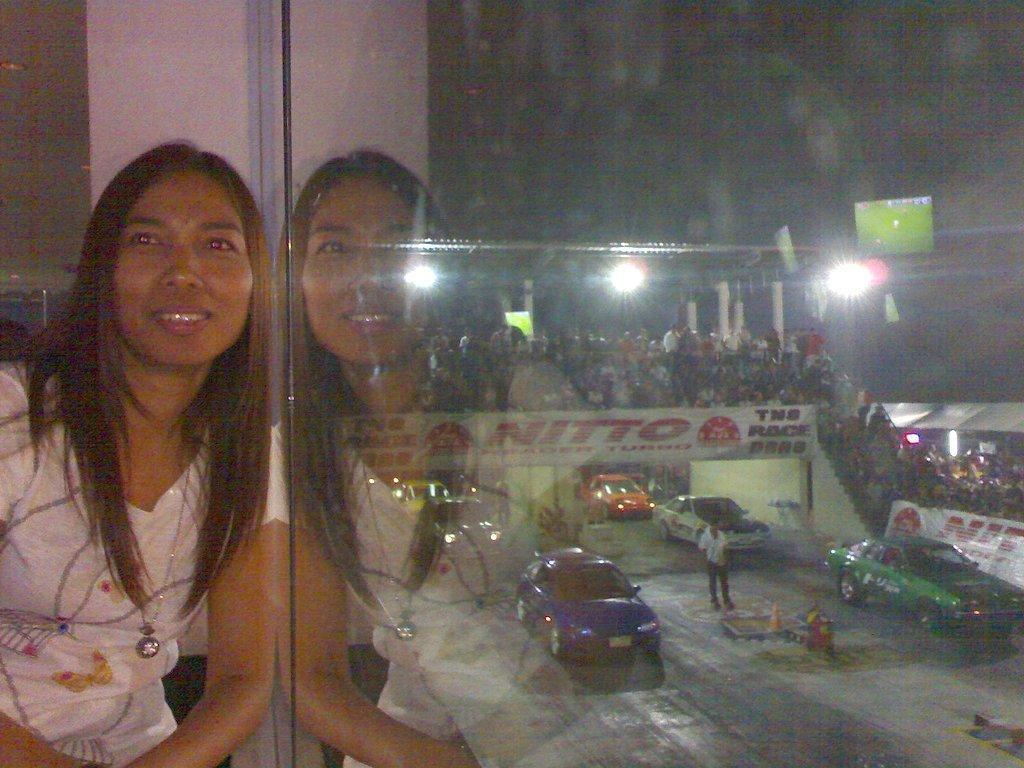In one or two sentences, can you explain what this image depicts? In this image we can see a woman and her reflection on the glass. On the backside we can see some vehicles, a traffic pole and a person standing on the road. We can also see a group of people, a staircase, a banner, a board with some text on it, a display screen and some lights. 